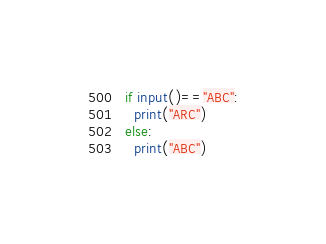<code> <loc_0><loc_0><loc_500><loc_500><_Python_>if input()=="ABC":
  print("ARC")
else:
  print("ABC")</code> 